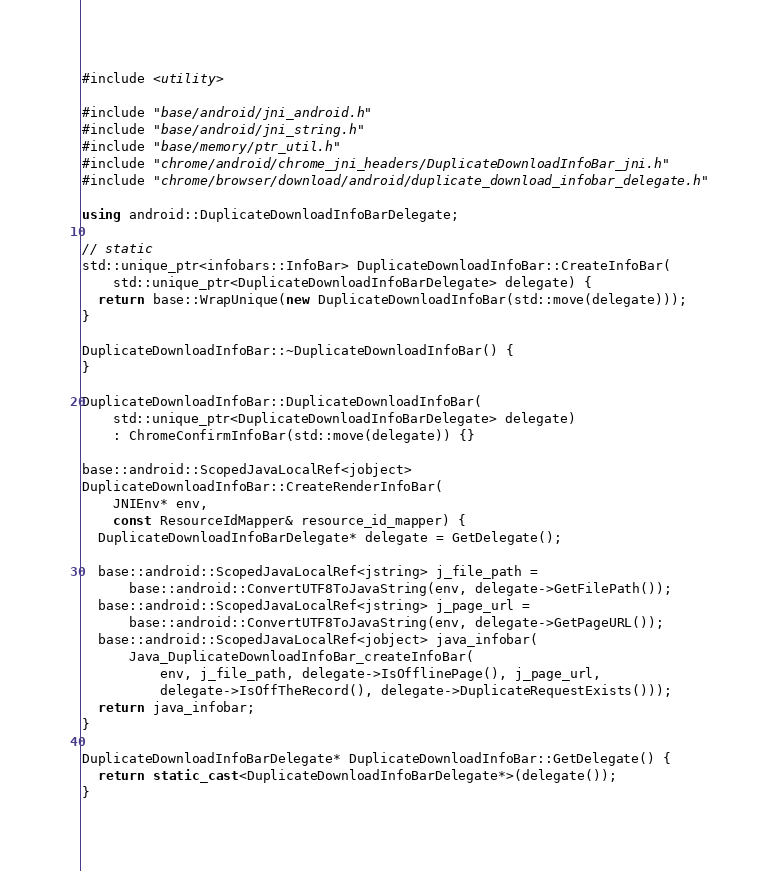Convert code to text. <code><loc_0><loc_0><loc_500><loc_500><_C++_>#include <utility>

#include "base/android/jni_android.h"
#include "base/android/jni_string.h"
#include "base/memory/ptr_util.h"
#include "chrome/android/chrome_jni_headers/DuplicateDownloadInfoBar_jni.h"
#include "chrome/browser/download/android/duplicate_download_infobar_delegate.h"

using android::DuplicateDownloadInfoBarDelegate;

// static
std::unique_ptr<infobars::InfoBar> DuplicateDownloadInfoBar::CreateInfoBar(
    std::unique_ptr<DuplicateDownloadInfoBarDelegate> delegate) {
  return base::WrapUnique(new DuplicateDownloadInfoBar(std::move(delegate)));
}

DuplicateDownloadInfoBar::~DuplicateDownloadInfoBar() {
}

DuplicateDownloadInfoBar::DuplicateDownloadInfoBar(
    std::unique_ptr<DuplicateDownloadInfoBarDelegate> delegate)
    : ChromeConfirmInfoBar(std::move(delegate)) {}

base::android::ScopedJavaLocalRef<jobject>
DuplicateDownloadInfoBar::CreateRenderInfoBar(
    JNIEnv* env,
    const ResourceIdMapper& resource_id_mapper) {
  DuplicateDownloadInfoBarDelegate* delegate = GetDelegate();

  base::android::ScopedJavaLocalRef<jstring> j_file_path =
      base::android::ConvertUTF8ToJavaString(env, delegate->GetFilePath());
  base::android::ScopedJavaLocalRef<jstring> j_page_url =
      base::android::ConvertUTF8ToJavaString(env, delegate->GetPageURL());
  base::android::ScopedJavaLocalRef<jobject> java_infobar(
      Java_DuplicateDownloadInfoBar_createInfoBar(
          env, j_file_path, delegate->IsOfflinePage(), j_page_url,
          delegate->IsOffTheRecord(), delegate->DuplicateRequestExists()));
  return java_infobar;
}

DuplicateDownloadInfoBarDelegate* DuplicateDownloadInfoBar::GetDelegate() {
  return static_cast<DuplicateDownloadInfoBarDelegate*>(delegate());
}
</code> 